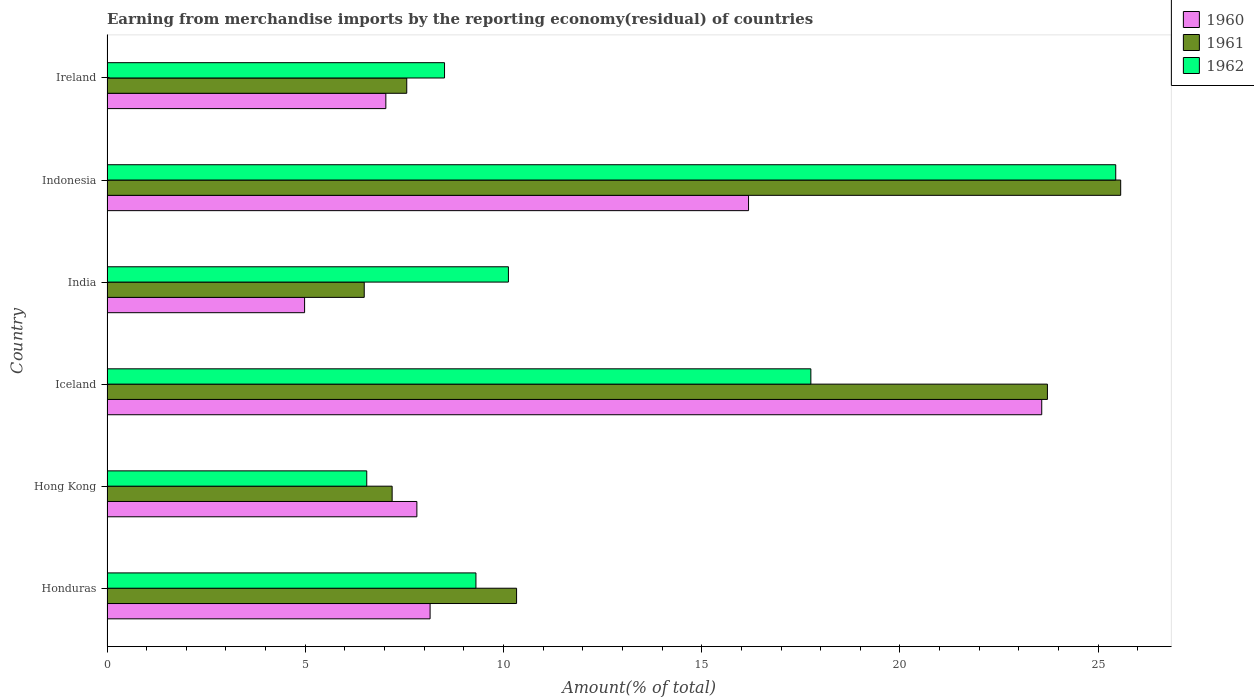How many different coloured bars are there?
Your answer should be very brief. 3. Are the number of bars per tick equal to the number of legend labels?
Give a very brief answer. Yes. Are the number of bars on each tick of the Y-axis equal?
Give a very brief answer. Yes. How many bars are there on the 6th tick from the top?
Provide a short and direct response. 3. How many bars are there on the 5th tick from the bottom?
Your answer should be compact. 3. What is the label of the 4th group of bars from the top?
Keep it short and to the point. Iceland. What is the percentage of amount earned from merchandise imports in 1961 in Ireland?
Give a very brief answer. 7.56. Across all countries, what is the maximum percentage of amount earned from merchandise imports in 1962?
Offer a very short reply. 25.44. Across all countries, what is the minimum percentage of amount earned from merchandise imports in 1960?
Offer a terse response. 4.98. In which country was the percentage of amount earned from merchandise imports in 1962 minimum?
Provide a succinct answer. Hong Kong. What is the total percentage of amount earned from merchandise imports in 1960 in the graph?
Ensure brevity in your answer.  67.74. What is the difference between the percentage of amount earned from merchandise imports in 1962 in Honduras and that in Iceland?
Ensure brevity in your answer.  -8.45. What is the difference between the percentage of amount earned from merchandise imports in 1961 in Honduras and the percentage of amount earned from merchandise imports in 1960 in Indonesia?
Give a very brief answer. -5.85. What is the average percentage of amount earned from merchandise imports in 1961 per country?
Offer a very short reply. 13.48. What is the difference between the percentage of amount earned from merchandise imports in 1961 and percentage of amount earned from merchandise imports in 1960 in India?
Your answer should be very brief. 1.5. In how many countries, is the percentage of amount earned from merchandise imports in 1960 greater than 4 %?
Provide a short and direct response. 6. What is the ratio of the percentage of amount earned from merchandise imports in 1961 in Hong Kong to that in India?
Your response must be concise. 1.11. What is the difference between the highest and the second highest percentage of amount earned from merchandise imports in 1960?
Your response must be concise. 7.4. What is the difference between the highest and the lowest percentage of amount earned from merchandise imports in 1962?
Ensure brevity in your answer.  18.89. What does the 2nd bar from the top in Ireland represents?
Offer a terse response. 1961. Is it the case that in every country, the sum of the percentage of amount earned from merchandise imports in 1960 and percentage of amount earned from merchandise imports in 1962 is greater than the percentage of amount earned from merchandise imports in 1961?
Provide a short and direct response. Yes. Are all the bars in the graph horizontal?
Give a very brief answer. Yes. What is the difference between two consecutive major ticks on the X-axis?
Offer a very short reply. 5. Does the graph contain grids?
Keep it short and to the point. No. Where does the legend appear in the graph?
Offer a very short reply. Top right. How many legend labels are there?
Give a very brief answer. 3. How are the legend labels stacked?
Provide a succinct answer. Vertical. What is the title of the graph?
Your response must be concise. Earning from merchandise imports by the reporting economy(residual) of countries. What is the label or title of the X-axis?
Ensure brevity in your answer.  Amount(% of total). What is the label or title of the Y-axis?
Offer a very short reply. Country. What is the Amount(% of total) in 1960 in Honduras?
Give a very brief answer. 8.15. What is the Amount(% of total) of 1961 in Honduras?
Your answer should be compact. 10.33. What is the Amount(% of total) in 1962 in Honduras?
Your response must be concise. 9.31. What is the Amount(% of total) of 1960 in Hong Kong?
Offer a terse response. 7.82. What is the Amount(% of total) in 1961 in Hong Kong?
Provide a short and direct response. 7.19. What is the Amount(% of total) of 1962 in Hong Kong?
Your answer should be compact. 6.55. What is the Amount(% of total) of 1960 in Iceland?
Your response must be concise. 23.58. What is the Amount(% of total) of 1961 in Iceland?
Your answer should be compact. 23.72. What is the Amount(% of total) of 1962 in Iceland?
Keep it short and to the point. 17.75. What is the Amount(% of total) in 1960 in India?
Make the answer very short. 4.98. What is the Amount(% of total) in 1961 in India?
Your answer should be very brief. 6.49. What is the Amount(% of total) in 1962 in India?
Your answer should be very brief. 10.12. What is the Amount(% of total) in 1960 in Indonesia?
Offer a very short reply. 16.18. What is the Amount(% of total) in 1961 in Indonesia?
Ensure brevity in your answer.  25.57. What is the Amount(% of total) of 1962 in Indonesia?
Offer a very short reply. 25.44. What is the Amount(% of total) of 1960 in Ireland?
Offer a terse response. 7.03. What is the Amount(% of total) of 1961 in Ireland?
Provide a short and direct response. 7.56. What is the Amount(% of total) of 1962 in Ireland?
Your answer should be compact. 8.51. Across all countries, what is the maximum Amount(% of total) of 1960?
Your answer should be compact. 23.58. Across all countries, what is the maximum Amount(% of total) of 1961?
Make the answer very short. 25.57. Across all countries, what is the maximum Amount(% of total) in 1962?
Keep it short and to the point. 25.44. Across all countries, what is the minimum Amount(% of total) in 1960?
Make the answer very short. 4.98. Across all countries, what is the minimum Amount(% of total) in 1961?
Provide a short and direct response. 6.49. Across all countries, what is the minimum Amount(% of total) in 1962?
Give a very brief answer. 6.55. What is the total Amount(% of total) of 1960 in the graph?
Keep it short and to the point. 67.74. What is the total Amount(% of total) of 1961 in the graph?
Provide a short and direct response. 80.86. What is the total Amount(% of total) in 1962 in the graph?
Provide a succinct answer. 77.69. What is the difference between the Amount(% of total) of 1960 in Honduras and that in Hong Kong?
Offer a terse response. 0.33. What is the difference between the Amount(% of total) in 1961 in Honduras and that in Hong Kong?
Ensure brevity in your answer.  3.14. What is the difference between the Amount(% of total) of 1962 in Honduras and that in Hong Kong?
Ensure brevity in your answer.  2.75. What is the difference between the Amount(% of total) in 1960 in Honduras and that in Iceland?
Provide a short and direct response. -15.43. What is the difference between the Amount(% of total) in 1961 in Honduras and that in Iceland?
Ensure brevity in your answer.  -13.39. What is the difference between the Amount(% of total) in 1962 in Honduras and that in Iceland?
Your answer should be compact. -8.45. What is the difference between the Amount(% of total) in 1960 in Honduras and that in India?
Provide a short and direct response. 3.17. What is the difference between the Amount(% of total) of 1961 in Honduras and that in India?
Your answer should be very brief. 3.84. What is the difference between the Amount(% of total) of 1962 in Honduras and that in India?
Keep it short and to the point. -0.82. What is the difference between the Amount(% of total) of 1960 in Honduras and that in Indonesia?
Provide a succinct answer. -8.03. What is the difference between the Amount(% of total) of 1961 in Honduras and that in Indonesia?
Offer a very short reply. -15.24. What is the difference between the Amount(% of total) of 1962 in Honduras and that in Indonesia?
Your answer should be very brief. -16.14. What is the difference between the Amount(% of total) in 1960 in Honduras and that in Ireland?
Your response must be concise. 1.12. What is the difference between the Amount(% of total) in 1961 in Honduras and that in Ireland?
Provide a short and direct response. 2.77. What is the difference between the Amount(% of total) in 1962 in Honduras and that in Ireland?
Your answer should be compact. 0.79. What is the difference between the Amount(% of total) of 1960 in Hong Kong and that in Iceland?
Offer a terse response. -15.76. What is the difference between the Amount(% of total) of 1961 in Hong Kong and that in Iceland?
Offer a very short reply. -16.53. What is the difference between the Amount(% of total) of 1962 in Hong Kong and that in Iceland?
Give a very brief answer. -11.2. What is the difference between the Amount(% of total) of 1960 in Hong Kong and that in India?
Keep it short and to the point. 2.83. What is the difference between the Amount(% of total) in 1961 in Hong Kong and that in India?
Provide a succinct answer. 0.7. What is the difference between the Amount(% of total) in 1962 in Hong Kong and that in India?
Offer a very short reply. -3.57. What is the difference between the Amount(% of total) of 1960 in Hong Kong and that in Indonesia?
Offer a terse response. -8.37. What is the difference between the Amount(% of total) of 1961 in Hong Kong and that in Indonesia?
Offer a terse response. -18.38. What is the difference between the Amount(% of total) of 1962 in Hong Kong and that in Indonesia?
Your response must be concise. -18.89. What is the difference between the Amount(% of total) of 1960 in Hong Kong and that in Ireland?
Your response must be concise. 0.78. What is the difference between the Amount(% of total) in 1961 in Hong Kong and that in Ireland?
Your answer should be very brief. -0.37. What is the difference between the Amount(% of total) in 1962 in Hong Kong and that in Ireland?
Keep it short and to the point. -1.96. What is the difference between the Amount(% of total) in 1960 in Iceland and that in India?
Provide a succinct answer. 18.59. What is the difference between the Amount(% of total) of 1961 in Iceland and that in India?
Ensure brevity in your answer.  17.23. What is the difference between the Amount(% of total) in 1962 in Iceland and that in India?
Your response must be concise. 7.63. What is the difference between the Amount(% of total) of 1960 in Iceland and that in Indonesia?
Give a very brief answer. 7.4. What is the difference between the Amount(% of total) of 1961 in Iceland and that in Indonesia?
Provide a short and direct response. -1.85. What is the difference between the Amount(% of total) in 1962 in Iceland and that in Indonesia?
Ensure brevity in your answer.  -7.69. What is the difference between the Amount(% of total) of 1960 in Iceland and that in Ireland?
Make the answer very short. 16.54. What is the difference between the Amount(% of total) in 1961 in Iceland and that in Ireland?
Keep it short and to the point. 16.16. What is the difference between the Amount(% of total) in 1962 in Iceland and that in Ireland?
Your answer should be very brief. 9.24. What is the difference between the Amount(% of total) in 1960 in India and that in Indonesia?
Offer a very short reply. -11.2. What is the difference between the Amount(% of total) of 1961 in India and that in Indonesia?
Offer a very short reply. -19.08. What is the difference between the Amount(% of total) of 1962 in India and that in Indonesia?
Provide a short and direct response. -15.32. What is the difference between the Amount(% of total) in 1960 in India and that in Ireland?
Ensure brevity in your answer.  -2.05. What is the difference between the Amount(% of total) of 1961 in India and that in Ireland?
Your answer should be very brief. -1.07. What is the difference between the Amount(% of total) of 1962 in India and that in Ireland?
Provide a short and direct response. 1.61. What is the difference between the Amount(% of total) in 1960 in Indonesia and that in Ireland?
Keep it short and to the point. 9.15. What is the difference between the Amount(% of total) in 1961 in Indonesia and that in Ireland?
Ensure brevity in your answer.  18.01. What is the difference between the Amount(% of total) in 1962 in Indonesia and that in Ireland?
Your answer should be very brief. 16.93. What is the difference between the Amount(% of total) of 1960 in Honduras and the Amount(% of total) of 1961 in Hong Kong?
Provide a short and direct response. 0.96. What is the difference between the Amount(% of total) of 1960 in Honduras and the Amount(% of total) of 1962 in Hong Kong?
Ensure brevity in your answer.  1.6. What is the difference between the Amount(% of total) in 1961 in Honduras and the Amount(% of total) in 1962 in Hong Kong?
Ensure brevity in your answer.  3.78. What is the difference between the Amount(% of total) of 1960 in Honduras and the Amount(% of total) of 1961 in Iceland?
Give a very brief answer. -15.57. What is the difference between the Amount(% of total) in 1960 in Honduras and the Amount(% of total) in 1962 in Iceland?
Ensure brevity in your answer.  -9.6. What is the difference between the Amount(% of total) in 1961 in Honduras and the Amount(% of total) in 1962 in Iceland?
Your response must be concise. -7.42. What is the difference between the Amount(% of total) of 1960 in Honduras and the Amount(% of total) of 1961 in India?
Provide a short and direct response. 1.66. What is the difference between the Amount(% of total) of 1960 in Honduras and the Amount(% of total) of 1962 in India?
Provide a succinct answer. -1.98. What is the difference between the Amount(% of total) in 1961 in Honduras and the Amount(% of total) in 1962 in India?
Make the answer very short. 0.21. What is the difference between the Amount(% of total) of 1960 in Honduras and the Amount(% of total) of 1961 in Indonesia?
Make the answer very short. -17.42. What is the difference between the Amount(% of total) in 1960 in Honduras and the Amount(% of total) in 1962 in Indonesia?
Keep it short and to the point. -17.29. What is the difference between the Amount(% of total) in 1961 in Honduras and the Amount(% of total) in 1962 in Indonesia?
Give a very brief answer. -15.11. What is the difference between the Amount(% of total) of 1960 in Honduras and the Amount(% of total) of 1961 in Ireland?
Offer a terse response. 0.59. What is the difference between the Amount(% of total) of 1960 in Honduras and the Amount(% of total) of 1962 in Ireland?
Offer a terse response. -0.36. What is the difference between the Amount(% of total) in 1961 in Honduras and the Amount(% of total) in 1962 in Ireland?
Keep it short and to the point. 1.82. What is the difference between the Amount(% of total) in 1960 in Hong Kong and the Amount(% of total) in 1961 in Iceland?
Offer a terse response. -15.9. What is the difference between the Amount(% of total) in 1960 in Hong Kong and the Amount(% of total) in 1962 in Iceland?
Your answer should be very brief. -9.94. What is the difference between the Amount(% of total) in 1961 in Hong Kong and the Amount(% of total) in 1962 in Iceland?
Give a very brief answer. -10.56. What is the difference between the Amount(% of total) of 1960 in Hong Kong and the Amount(% of total) of 1961 in India?
Your response must be concise. 1.33. What is the difference between the Amount(% of total) in 1960 in Hong Kong and the Amount(% of total) in 1962 in India?
Ensure brevity in your answer.  -2.31. What is the difference between the Amount(% of total) of 1961 in Hong Kong and the Amount(% of total) of 1962 in India?
Give a very brief answer. -2.93. What is the difference between the Amount(% of total) of 1960 in Hong Kong and the Amount(% of total) of 1961 in Indonesia?
Offer a terse response. -17.75. What is the difference between the Amount(% of total) in 1960 in Hong Kong and the Amount(% of total) in 1962 in Indonesia?
Ensure brevity in your answer.  -17.63. What is the difference between the Amount(% of total) in 1961 in Hong Kong and the Amount(% of total) in 1962 in Indonesia?
Your response must be concise. -18.25. What is the difference between the Amount(% of total) in 1960 in Hong Kong and the Amount(% of total) in 1961 in Ireland?
Your answer should be compact. 0.26. What is the difference between the Amount(% of total) of 1960 in Hong Kong and the Amount(% of total) of 1962 in Ireland?
Keep it short and to the point. -0.7. What is the difference between the Amount(% of total) of 1961 in Hong Kong and the Amount(% of total) of 1962 in Ireland?
Ensure brevity in your answer.  -1.32. What is the difference between the Amount(% of total) in 1960 in Iceland and the Amount(% of total) in 1961 in India?
Keep it short and to the point. 17.09. What is the difference between the Amount(% of total) in 1960 in Iceland and the Amount(% of total) in 1962 in India?
Make the answer very short. 13.45. What is the difference between the Amount(% of total) in 1961 in Iceland and the Amount(% of total) in 1962 in India?
Keep it short and to the point. 13.6. What is the difference between the Amount(% of total) in 1960 in Iceland and the Amount(% of total) in 1961 in Indonesia?
Ensure brevity in your answer.  -1.99. What is the difference between the Amount(% of total) of 1960 in Iceland and the Amount(% of total) of 1962 in Indonesia?
Your response must be concise. -1.87. What is the difference between the Amount(% of total) in 1961 in Iceland and the Amount(% of total) in 1962 in Indonesia?
Your answer should be compact. -1.72. What is the difference between the Amount(% of total) of 1960 in Iceland and the Amount(% of total) of 1961 in Ireland?
Keep it short and to the point. 16.02. What is the difference between the Amount(% of total) of 1960 in Iceland and the Amount(% of total) of 1962 in Ireland?
Ensure brevity in your answer.  15.06. What is the difference between the Amount(% of total) of 1961 in Iceland and the Amount(% of total) of 1962 in Ireland?
Make the answer very short. 15.21. What is the difference between the Amount(% of total) of 1960 in India and the Amount(% of total) of 1961 in Indonesia?
Offer a very short reply. -20.58. What is the difference between the Amount(% of total) in 1960 in India and the Amount(% of total) in 1962 in Indonesia?
Make the answer very short. -20.46. What is the difference between the Amount(% of total) of 1961 in India and the Amount(% of total) of 1962 in Indonesia?
Keep it short and to the point. -18.95. What is the difference between the Amount(% of total) in 1960 in India and the Amount(% of total) in 1961 in Ireland?
Provide a succinct answer. -2.58. What is the difference between the Amount(% of total) in 1960 in India and the Amount(% of total) in 1962 in Ireland?
Provide a short and direct response. -3.53. What is the difference between the Amount(% of total) in 1961 in India and the Amount(% of total) in 1962 in Ireland?
Your answer should be compact. -2.03. What is the difference between the Amount(% of total) of 1960 in Indonesia and the Amount(% of total) of 1961 in Ireland?
Keep it short and to the point. 8.62. What is the difference between the Amount(% of total) of 1960 in Indonesia and the Amount(% of total) of 1962 in Ireland?
Give a very brief answer. 7.67. What is the difference between the Amount(% of total) in 1961 in Indonesia and the Amount(% of total) in 1962 in Ireland?
Your answer should be very brief. 17.05. What is the average Amount(% of total) of 1960 per country?
Provide a succinct answer. 11.29. What is the average Amount(% of total) in 1961 per country?
Your answer should be compact. 13.48. What is the average Amount(% of total) of 1962 per country?
Offer a terse response. 12.95. What is the difference between the Amount(% of total) of 1960 and Amount(% of total) of 1961 in Honduras?
Offer a terse response. -2.18. What is the difference between the Amount(% of total) of 1960 and Amount(% of total) of 1962 in Honduras?
Provide a short and direct response. -1.16. What is the difference between the Amount(% of total) in 1961 and Amount(% of total) in 1962 in Honduras?
Offer a terse response. 1.03. What is the difference between the Amount(% of total) in 1960 and Amount(% of total) in 1961 in Hong Kong?
Ensure brevity in your answer.  0.62. What is the difference between the Amount(% of total) in 1960 and Amount(% of total) in 1962 in Hong Kong?
Offer a terse response. 1.26. What is the difference between the Amount(% of total) in 1961 and Amount(% of total) in 1962 in Hong Kong?
Your answer should be very brief. 0.64. What is the difference between the Amount(% of total) of 1960 and Amount(% of total) of 1961 in Iceland?
Give a very brief answer. -0.14. What is the difference between the Amount(% of total) in 1960 and Amount(% of total) in 1962 in Iceland?
Your answer should be very brief. 5.82. What is the difference between the Amount(% of total) of 1961 and Amount(% of total) of 1962 in Iceland?
Your answer should be compact. 5.97. What is the difference between the Amount(% of total) in 1960 and Amount(% of total) in 1961 in India?
Your answer should be compact. -1.5. What is the difference between the Amount(% of total) in 1960 and Amount(% of total) in 1962 in India?
Your answer should be very brief. -5.14. What is the difference between the Amount(% of total) of 1961 and Amount(% of total) of 1962 in India?
Provide a short and direct response. -3.64. What is the difference between the Amount(% of total) of 1960 and Amount(% of total) of 1961 in Indonesia?
Ensure brevity in your answer.  -9.39. What is the difference between the Amount(% of total) in 1960 and Amount(% of total) in 1962 in Indonesia?
Your answer should be compact. -9.26. What is the difference between the Amount(% of total) of 1961 and Amount(% of total) of 1962 in Indonesia?
Provide a succinct answer. 0.12. What is the difference between the Amount(% of total) in 1960 and Amount(% of total) in 1961 in Ireland?
Your answer should be compact. -0.53. What is the difference between the Amount(% of total) of 1960 and Amount(% of total) of 1962 in Ireland?
Your answer should be very brief. -1.48. What is the difference between the Amount(% of total) of 1961 and Amount(% of total) of 1962 in Ireland?
Offer a terse response. -0.95. What is the ratio of the Amount(% of total) in 1960 in Honduras to that in Hong Kong?
Your answer should be very brief. 1.04. What is the ratio of the Amount(% of total) of 1961 in Honduras to that in Hong Kong?
Keep it short and to the point. 1.44. What is the ratio of the Amount(% of total) of 1962 in Honduras to that in Hong Kong?
Ensure brevity in your answer.  1.42. What is the ratio of the Amount(% of total) of 1960 in Honduras to that in Iceland?
Your response must be concise. 0.35. What is the ratio of the Amount(% of total) of 1961 in Honduras to that in Iceland?
Your answer should be very brief. 0.44. What is the ratio of the Amount(% of total) of 1962 in Honduras to that in Iceland?
Make the answer very short. 0.52. What is the ratio of the Amount(% of total) of 1960 in Honduras to that in India?
Make the answer very short. 1.64. What is the ratio of the Amount(% of total) of 1961 in Honduras to that in India?
Your answer should be very brief. 1.59. What is the ratio of the Amount(% of total) in 1962 in Honduras to that in India?
Give a very brief answer. 0.92. What is the ratio of the Amount(% of total) in 1960 in Honduras to that in Indonesia?
Your answer should be very brief. 0.5. What is the ratio of the Amount(% of total) in 1961 in Honduras to that in Indonesia?
Offer a terse response. 0.4. What is the ratio of the Amount(% of total) in 1962 in Honduras to that in Indonesia?
Ensure brevity in your answer.  0.37. What is the ratio of the Amount(% of total) in 1960 in Honduras to that in Ireland?
Keep it short and to the point. 1.16. What is the ratio of the Amount(% of total) of 1961 in Honduras to that in Ireland?
Your answer should be very brief. 1.37. What is the ratio of the Amount(% of total) in 1962 in Honduras to that in Ireland?
Keep it short and to the point. 1.09. What is the ratio of the Amount(% of total) in 1960 in Hong Kong to that in Iceland?
Provide a succinct answer. 0.33. What is the ratio of the Amount(% of total) in 1961 in Hong Kong to that in Iceland?
Keep it short and to the point. 0.3. What is the ratio of the Amount(% of total) of 1962 in Hong Kong to that in Iceland?
Offer a very short reply. 0.37. What is the ratio of the Amount(% of total) of 1960 in Hong Kong to that in India?
Provide a succinct answer. 1.57. What is the ratio of the Amount(% of total) of 1961 in Hong Kong to that in India?
Offer a terse response. 1.11. What is the ratio of the Amount(% of total) in 1962 in Hong Kong to that in India?
Ensure brevity in your answer.  0.65. What is the ratio of the Amount(% of total) of 1960 in Hong Kong to that in Indonesia?
Your answer should be very brief. 0.48. What is the ratio of the Amount(% of total) in 1961 in Hong Kong to that in Indonesia?
Provide a short and direct response. 0.28. What is the ratio of the Amount(% of total) of 1962 in Hong Kong to that in Indonesia?
Provide a succinct answer. 0.26. What is the ratio of the Amount(% of total) of 1960 in Hong Kong to that in Ireland?
Your answer should be very brief. 1.11. What is the ratio of the Amount(% of total) in 1961 in Hong Kong to that in Ireland?
Offer a very short reply. 0.95. What is the ratio of the Amount(% of total) of 1962 in Hong Kong to that in Ireland?
Make the answer very short. 0.77. What is the ratio of the Amount(% of total) in 1960 in Iceland to that in India?
Ensure brevity in your answer.  4.73. What is the ratio of the Amount(% of total) in 1961 in Iceland to that in India?
Give a very brief answer. 3.66. What is the ratio of the Amount(% of total) in 1962 in Iceland to that in India?
Ensure brevity in your answer.  1.75. What is the ratio of the Amount(% of total) in 1960 in Iceland to that in Indonesia?
Provide a succinct answer. 1.46. What is the ratio of the Amount(% of total) in 1961 in Iceland to that in Indonesia?
Offer a terse response. 0.93. What is the ratio of the Amount(% of total) in 1962 in Iceland to that in Indonesia?
Your answer should be very brief. 0.7. What is the ratio of the Amount(% of total) in 1960 in Iceland to that in Ireland?
Make the answer very short. 3.35. What is the ratio of the Amount(% of total) in 1961 in Iceland to that in Ireland?
Make the answer very short. 3.14. What is the ratio of the Amount(% of total) in 1962 in Iceland to that in Ireland?
Ensure brevity in your answer.  2.09. What is the ratio of the Amount(% of total) of 1960 in India to that in Indonesia?
Give a very brief answer. 0.31. What is the ratio of the Amount(% of total) of 1961 in India to that in Indonesia?
Give a very brief answer. 0.25. What is the ratio of the Amount(% of total) in 1962 in India to that in Indonesia?
Keep it short and to the point. 0.4. What is the ratio of the Amount(% of total) of 1960 in India to that in Ireland?
Provide a short and direct response. 0.71. What is the ratio of the Amount(% of total) in 1961 in India to that in Ireland?
Your answer should be compact. 0.86. What is the ratio of the Amount(% of total) of 1962 in India to that in Ireland?
Offer a very short reply. 1.19. What is the ratio of the Amount(% of total) of 1960 in Indonesia to that in Ireland?
Your response must be concise. 2.3. What is the ratio of the Amount(% of total) in 1961 in Indonesia to that in Ireland?
Give a very brief answer. 3.38. What is the ratio of the Amount(% of total) of 1962 in Indonesia to that in Ireland?
Make the answer very short. 2.99. What is the difference between the highest and the second highest Amount(% of total) in 1960?
Keep it short and to the point. 7.4. What is the difference between the highest and the second highest Amount(% of total) of 1961?
Give a very brief answer. 1.85. What is the difference between the highest and the second highest Amount(% of total) in 1962?
Ensure brevity in your answer.  7.69. What is the difference between the highest and the lowest Amount(% of total) of 1960?
Your answer should be very brief. 18.59. What is the difference between the highest and the lowest Amount(% of total) in 1961?
Give a very brief answer. 19.08. What is the difference between the highest and the lowest Amount(% of total) of 1962?
Make the answer very short. 18.89. 